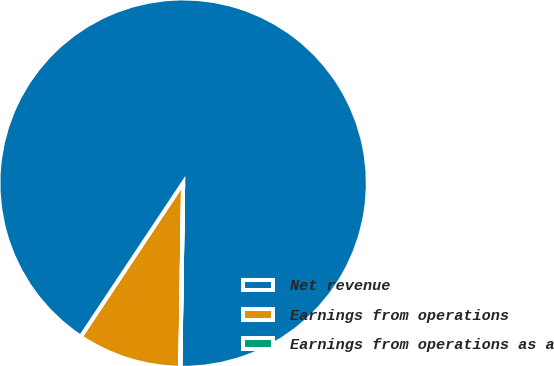Convert chart. <chart><loc_0><loc_0><loc_500><loc_500><pie_chart><fcel>Net revenue<fcel>Earnings from operations<fcel>Earnings from operations as a<nl><fcel>90.89%<fcel>9.1%<fcel>0.01%<nl></chart> 